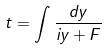Convert formula to latex. <formula><loc_0><loc_0><loc_500><loc_500>t = \int \frac { d y } { i y + F }</formula> 